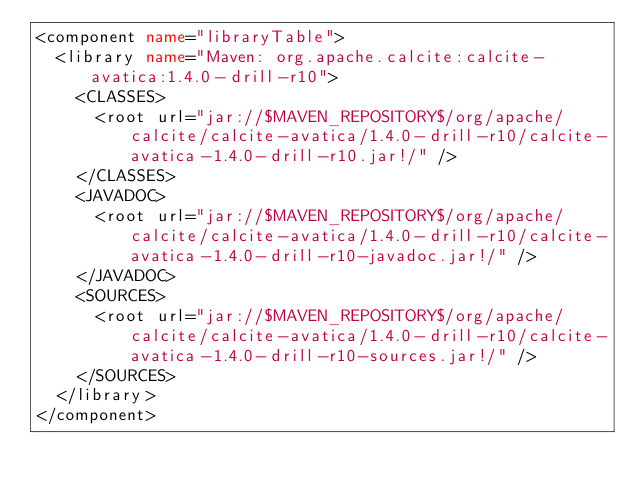Convert code to text. <code><loc_0><loc_0><loc_500><loc_500><_XML_><component name="libraryTable">
  <library name="Maven: org.apache.calcite:calcite-avatica:1.4.0-drill-r10">
    <CLASSES>
      <root url="jar://$MAVEN_REPOSITORY$/org/apache/calcite/calcite-avatica/1.4.0-drill-r10/calcite-avatica-1.4.0-drill-r10.jar!/" />
    </CLASSES>
    <JAVADOC>
      <root url="jar://$MAVEN_REPOSITORY$/org/apache/calcite/calcite-avatica/1.4.0-drill-r10/calcite-avatica-1.4.0-drill-r10-javadoc.jar!/" />
    </JAVADOC>
    <SOURCES>
      <root url="jar://$MAVEN_REPOSITORY$/org/apache/calcite/calcite-avatica/1.4.0-drill-r10/calcite-avatica-1.4.0-drill-r10-sources.jar!/" />
    </SOURCES>
  </library>
</component></code> 